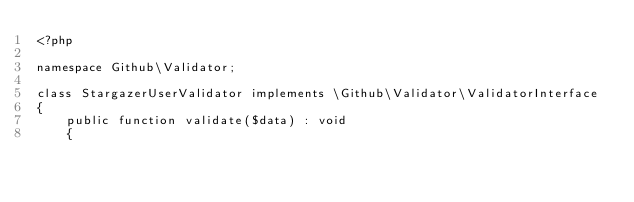<code> <loc_0><loc_0><loc_500><loc_500><_PHP_><?php

namespace Github\Validator;

class StargazerUserValidator implements \Github\Validator\ValidatorInterface
{
    public function validate($data) : void
    {</code> 